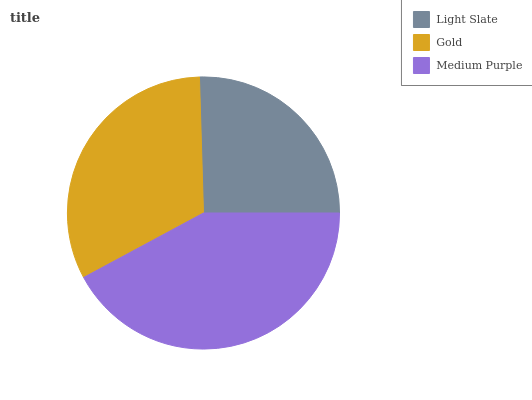Is Light Slate the minimum?
Answer yes or no. Yes. Is Medium Purple the maximum?
Answer yes or no. Yes. Is Gold the minimum?
Answer yes or no. No. Is Gold the maximum?
Answer yes or no. No. Is Gold greater than Light Slate?
Answer yes or no. Yes. Is Light Slate less than Gold?
Answer yes or no. Yes. Is Light Slate greater than Gold?
Answer yes or no. No. Is Gold less than Light Slate?
Answer yes or no. No. Is Gold the high median?
Answer yes or no. Yes. Is Gold the low median?
Answer yes or no. Yes. Is Light Slate the high median?
Answer yes or no. No. Is Medium Purple the low median?
Answer yes or no. No. 